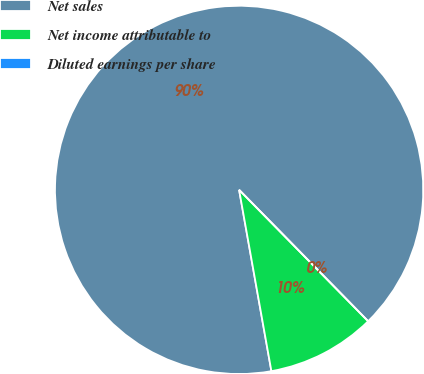Convert chart to OTSL. <chart><loc_0><loc_0><loc_500><loc_500><pie_chart><fcel>Net sales<fcel>Net income attributable to<fcel>Diluted earnings per share<nl><fcel>90.45%<fcel>9.55%<fcel>0.0%<nl></chart> 